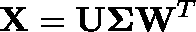Convert formula to latex. <formula><loc_0><loc_0><loc_500><loc_500>X = U \Sigma W ^ { T }</formula> 